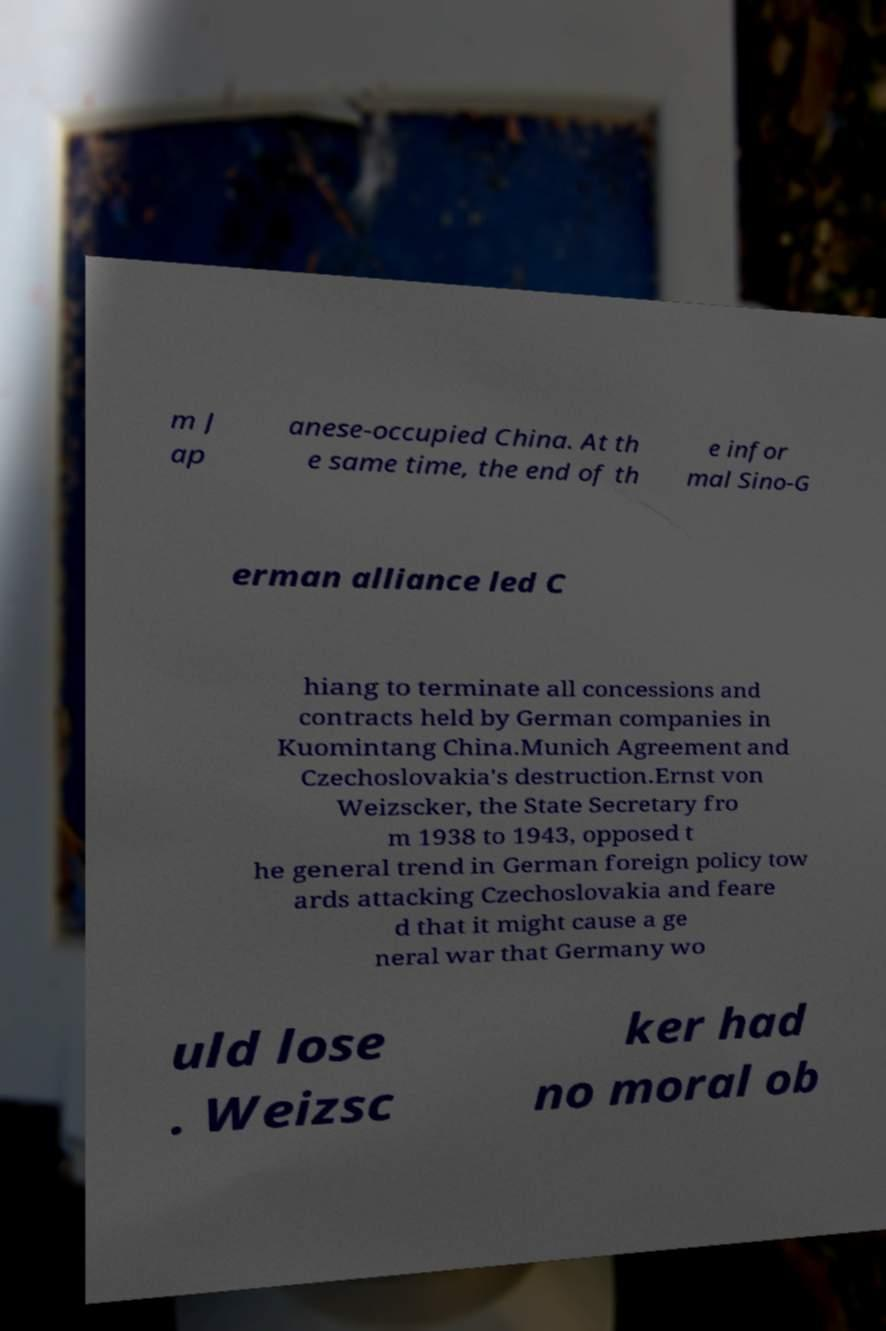Could you assist in decoding the text presented in this image and type it out clearly? m J ap anese-occupied China. At th e same time, the end of th e infor mal Sino-G erman alliance led C hiang to terminate all concessions and contracts held by German companies in Kuomintang China.Munich Agreement and Czechoslovakia's destruction.Ernst von Weizscker, the State Secretary fro m 1938 to 1943, opposed t he general trend in German foreign policy tow ards attacking Czechoslovakia and feare d that it might cause a ge neral war that Germany wo uld lose . Weizsc ker had no moral ob 